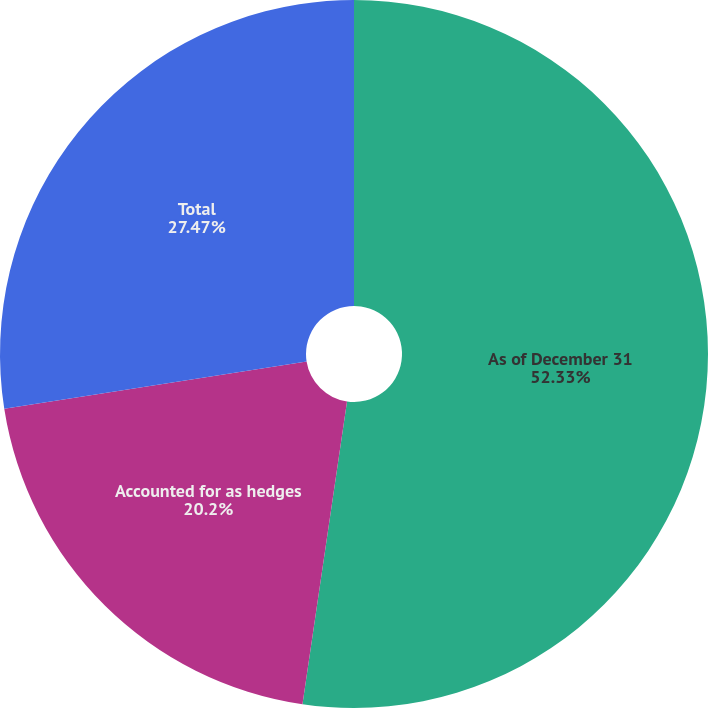Convert chart to OTSL. <chart><loc_0><loc_0><loc_500><loc_500><pie_chart><fcel>As of December 31<fcel>Accounted for as hedges<fcel>Total<nl><fcel>52.32%<fcel>20.2%<fcel>27.47%<nl></chart> 